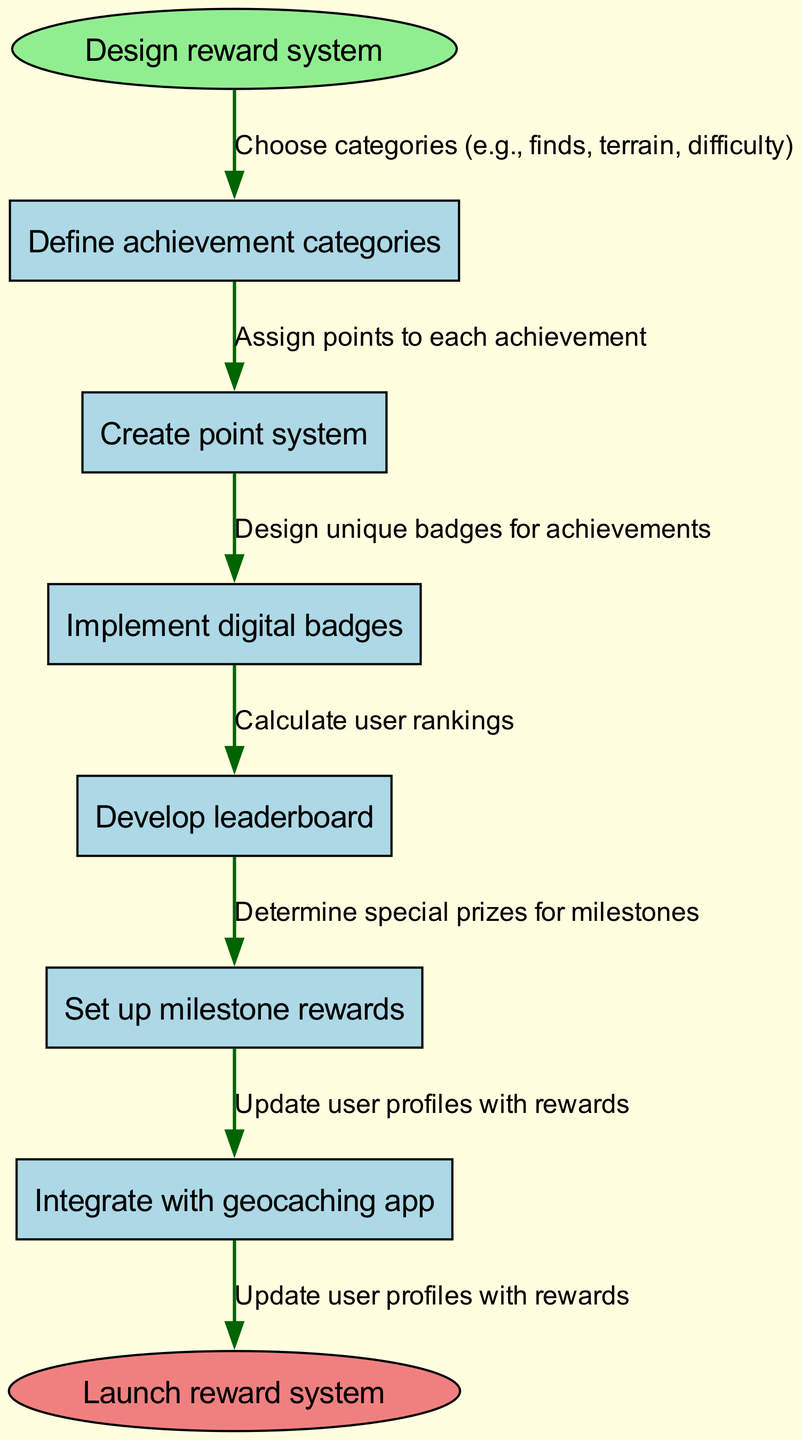What is the start node of the diagram? The first node, which signifies the beginning of the process, is labeled "Design reward system."
Answer: Design reward system How many nodes are in the diagram? Counting the start node, the end node, and all intermediate nodes, there are a total of 8 nodes in the diagram (1 start, 6 intermediate, and 1 end).
Answer: 8 What is the last intermediate node before the end node? The last intermediate node just before reaching the end node is "Integrate with geocaching app," which leads to the final step in the flow.
Answer: Integrate with geocaching app What is the edge describing the first step? The edge that connects the start node to the first intermediate node is "Choose categories (e.g., finds, terrain, difficulty)," indicating the first action to take.
Answer: Choose categories (e.g., finds, terrain, difficulty) Which achievement category is defined first in the flow? The first achievement category described within the nodes is "Define achievement categories," establishing the foundation of the reward system.
Answer: Define achievement categories What is the purpose of the "Develop leaderboard" step? The "Develop leaderboard" step calculates user rankings based on the points accumulated from their achievements, fostering competition among users of the app.
Answer: Calculate user rankings Which category has associated points assigned to it? The step "Create point system" indicates that points are assigned to each achievement category, essential for tracking user progress.
Answer: Points assigned to each achievement What milestone reward is mentioned at the end of the flow? The milestone reward is referred to as "Determine special prizes for milestones," signifying rewards for reaching particular achievement thresholds.
Answer: Determine special prizes for milestones 